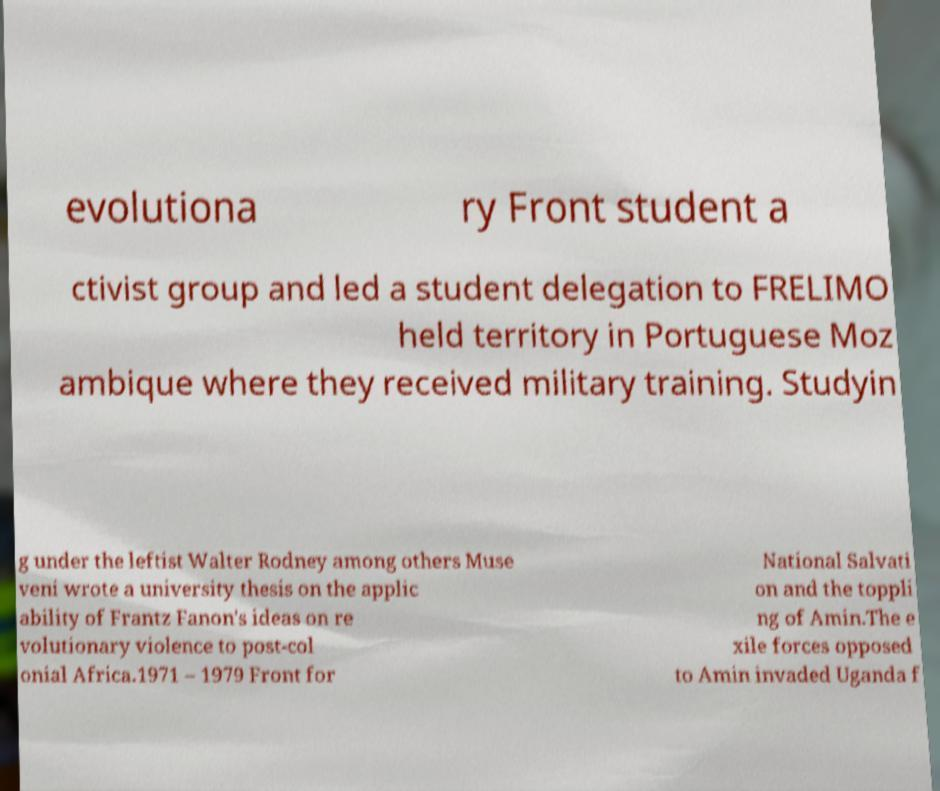Please identify and transcribe the text found in this image. evolutiona ry Front student a ctivist group and led a student delegation to FRELIMO held territory in Portuguese Moz ambique where they received military training. Studyin g under the leftist Walter Rodney among others Muse veni wrote a university thesis on the applic ability of Frantz Fanon's ideas on re volutionary violence to post-col onial Africa.1971 – 1979 Front for National Salvati on and the toppli ng of Amin.The e xile forces opposed to Amin invaded Uganda f 